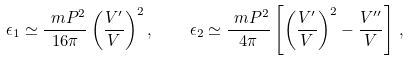<formula> <loc_0><loc_0><loc_500><loc_500>\epsilon _ { 1 } \simeq \frac { \ m P ^ { 2 } } { 1 6 \pi } \left ( \frac { V ^ { \prime } } { V } \right ) ^ { 2 } , \quad \epsilon _ { 2 } \simeq \frac { \ m P ^ { 2 } } { 4 \pi } \left [ \left ( \frac { V ^ { \prime } } { V } \right ) ^ { 2 } - \frac { V ^ { \prime \prime } } { V } \right ] \, ,</formula> 